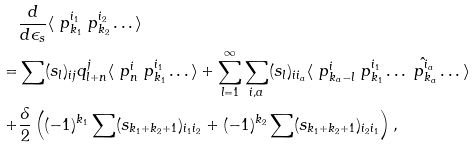Convert formula to latex. <formula><loc_0><loc_0><loc_500><loc_500>& \frac { d } { d \epsilon _ { s } } \langle \ p ^ { i _ { 1 } } _ { k _ { 1 } } \ p ^ { i _ { 2 } } _ { k _ { 2 } } \dots \rangle \\ = & \sum ( s _ { l } ) _ { i j } q ^ { j } _ { l + n } \langle \ p ^ { i } _ { n } \ p ^ { i _ { 1 } } _ { k _ { 1 } } \dots \rangle + \sum _ { l = 1 } ^ { \infty } \sum _ { i , a } ( s _ { l } ) _ { i i _ { a } } \langle \ p ^ { i } _ { k _ { a } - l } \ p ^ { i _ { 1 } } _ { k _ { 1 } } \dots \hat { \ p ^ { i _ { a } } _ { k _ { a } } } \dots \rangle \\ + & \frac { \delta } { 2 } \left ( ( - 1 ) ^ { k _ { 1 } } \sum ( s _ { k _ { 1 } + k _ { 2 } + 1 } ) _ { i _ { 1 } i _ { 2 } } + ( - 1 ) ^ { k _ { 2 } } \sum ( s _ { k _ { 1 } + k _ { 2 } + 1 } ) _ { i _ { 2 } i _ { 1 } } \right ) ,</formula> 